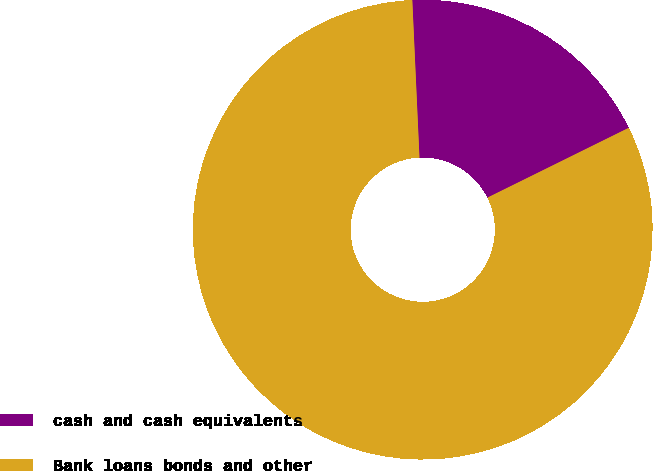<chart> <loc_0><loc_0><loc_500><loc_500><pie_chart><fcel>cash and cash equivalents<fcel>Bank loans bonds and other<nl><fcel>18.42%<fcel>81.58%<nl></chart> 